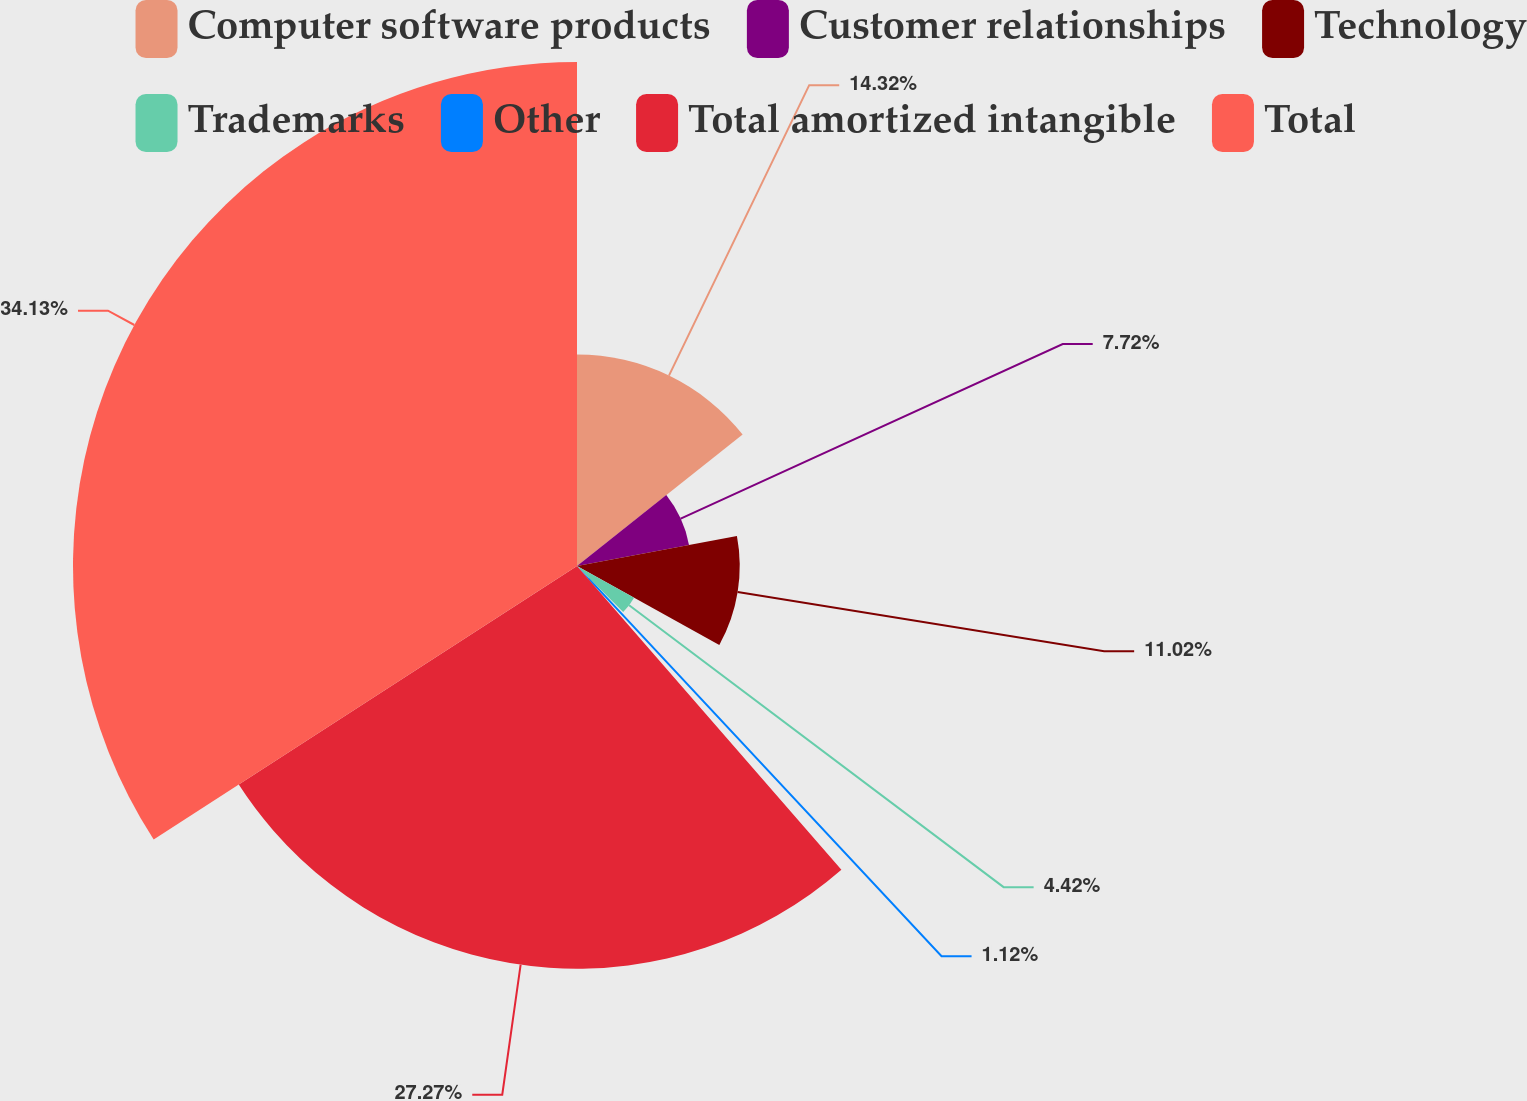<chart> <loc_0><loc_0><loc_500><loc_500><pie_chart><fcel>Computer software products<fcel>Customer relationships<fcel>Technology<fcel>Trademarks<fcel>Other<fcel>Total amortized intangible<fcel>Total<nl><fcel>14.32%<fcel>7.72%<fcel>11.02%<fcel>4.42%<fcel>1.12%<fcel>27.27%<fcel>34.13%<nl></chart> 